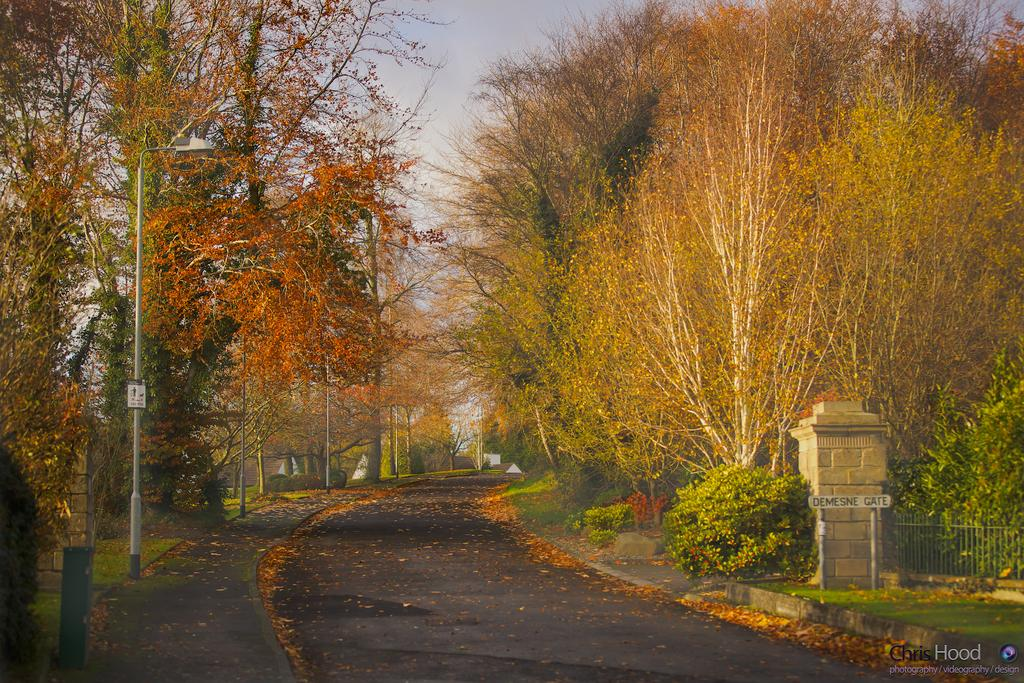What type of natural elements can be seen in the image? There are trees and plants in the image. What man-made structures are present in the image? There are poles, boards, pillars, a gate, and a road in the image. What is visible at the top of the image? The sky is visible at the top of the image. How many trains can be seen passing through the image? There are no trains present in the image. What type of credit is being offered to the people in the image? There is no credit or financial transaction depicted in the image. 